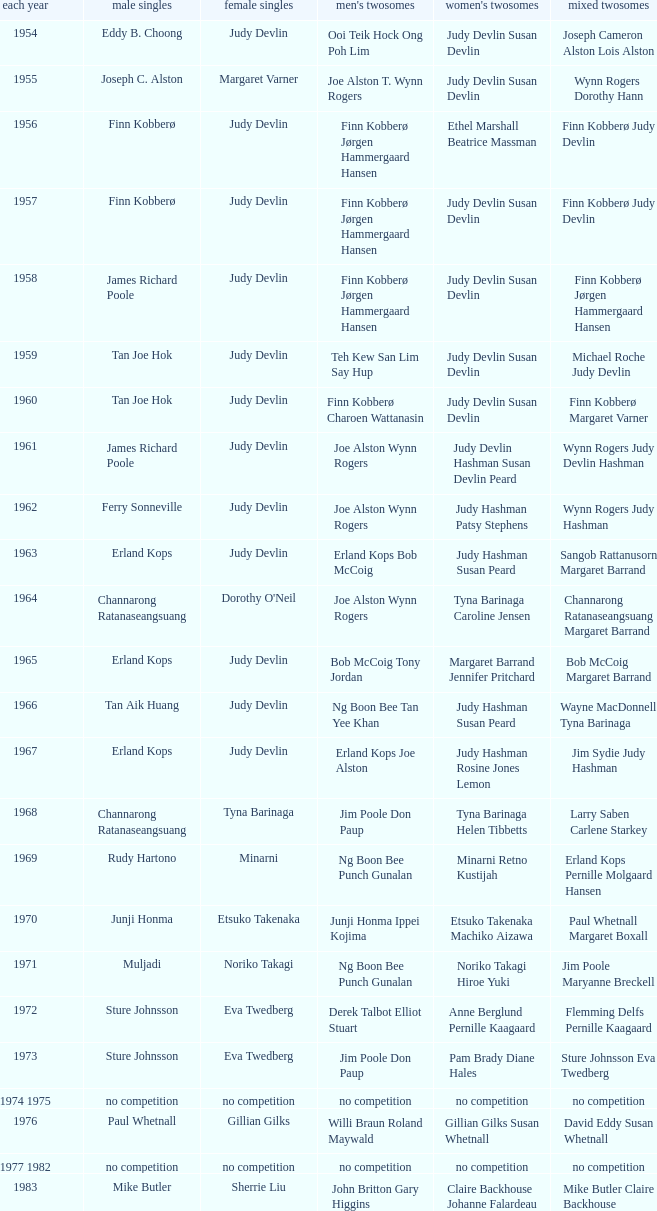Who was the women's singles champion in 1984? Luo Yun. 